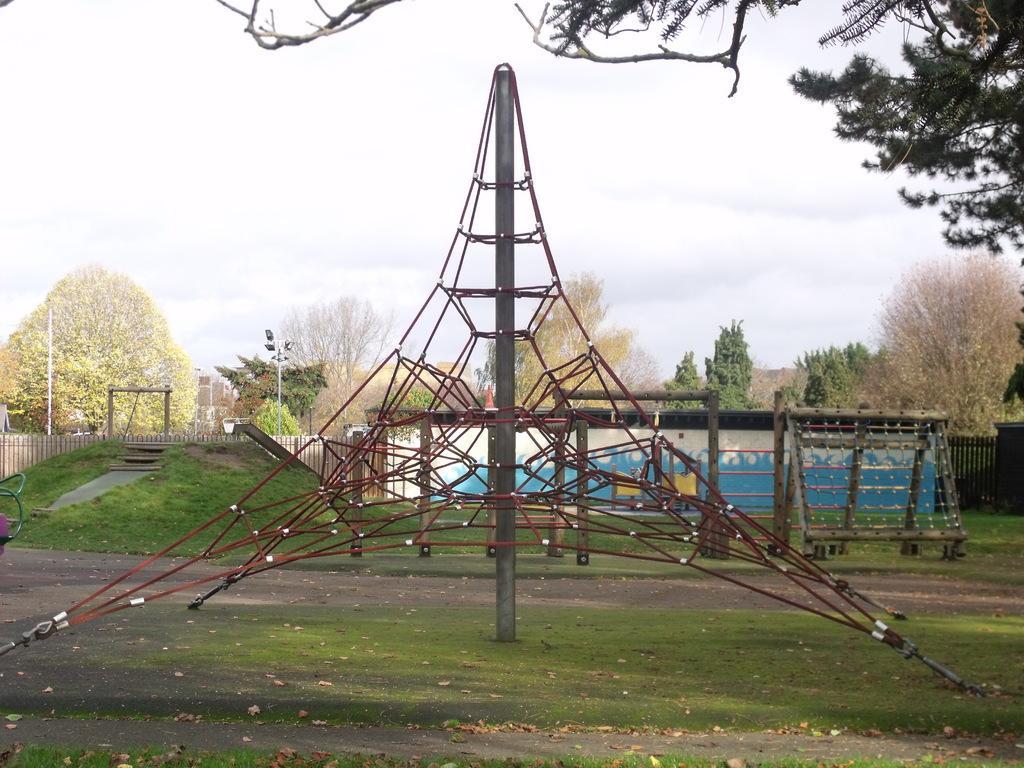Please provide a concise description of this image. In the picture we can see the grass surface on it, we can see some army training objects are placed and behind it, we can see the wall and behind it we can see the trees and the sky with clouds. 